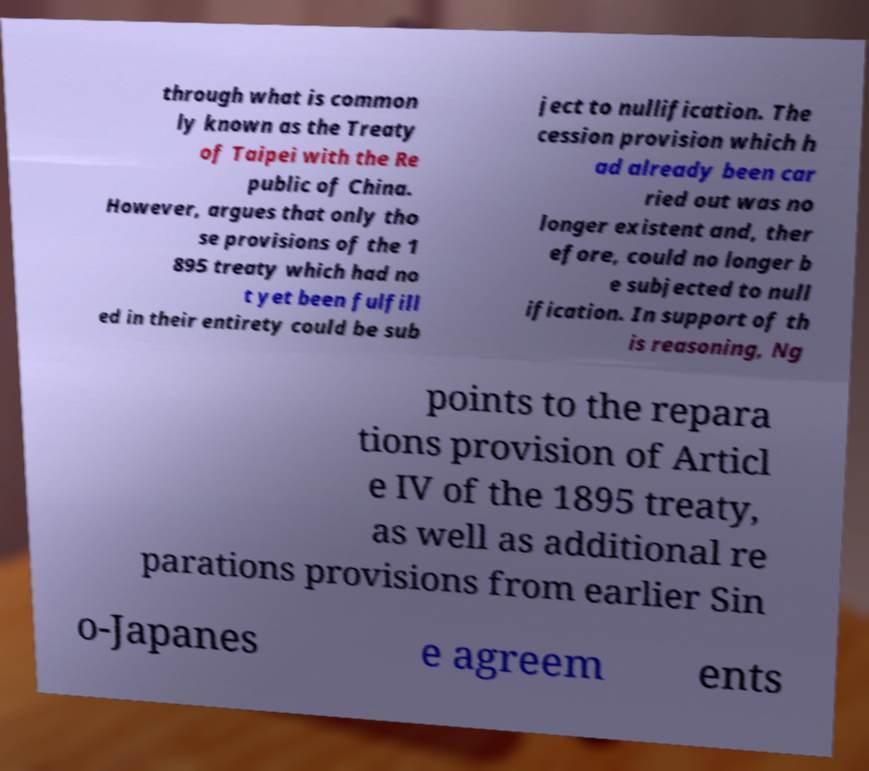For documentation purposes, I need the text within this image transcribed. Could you provide that? through what is common ly known as the Treaty of Taipei with the Re public of China. However, argues that only tho se provisions of the 1 895 treaty which had no t yet been fulfill ed in their entirety could be sub ject to nullification. The cession provision which h ad already been car ried out was no longer existent and, ther efore, could no longer b e subjected to null ification. In support of th is reasoning, Ng points to the repara tions provision of Articl e IV of the 1895 treaty, as well as additional re parations provisions from earlier Sin o-Japanes e agreem ents 